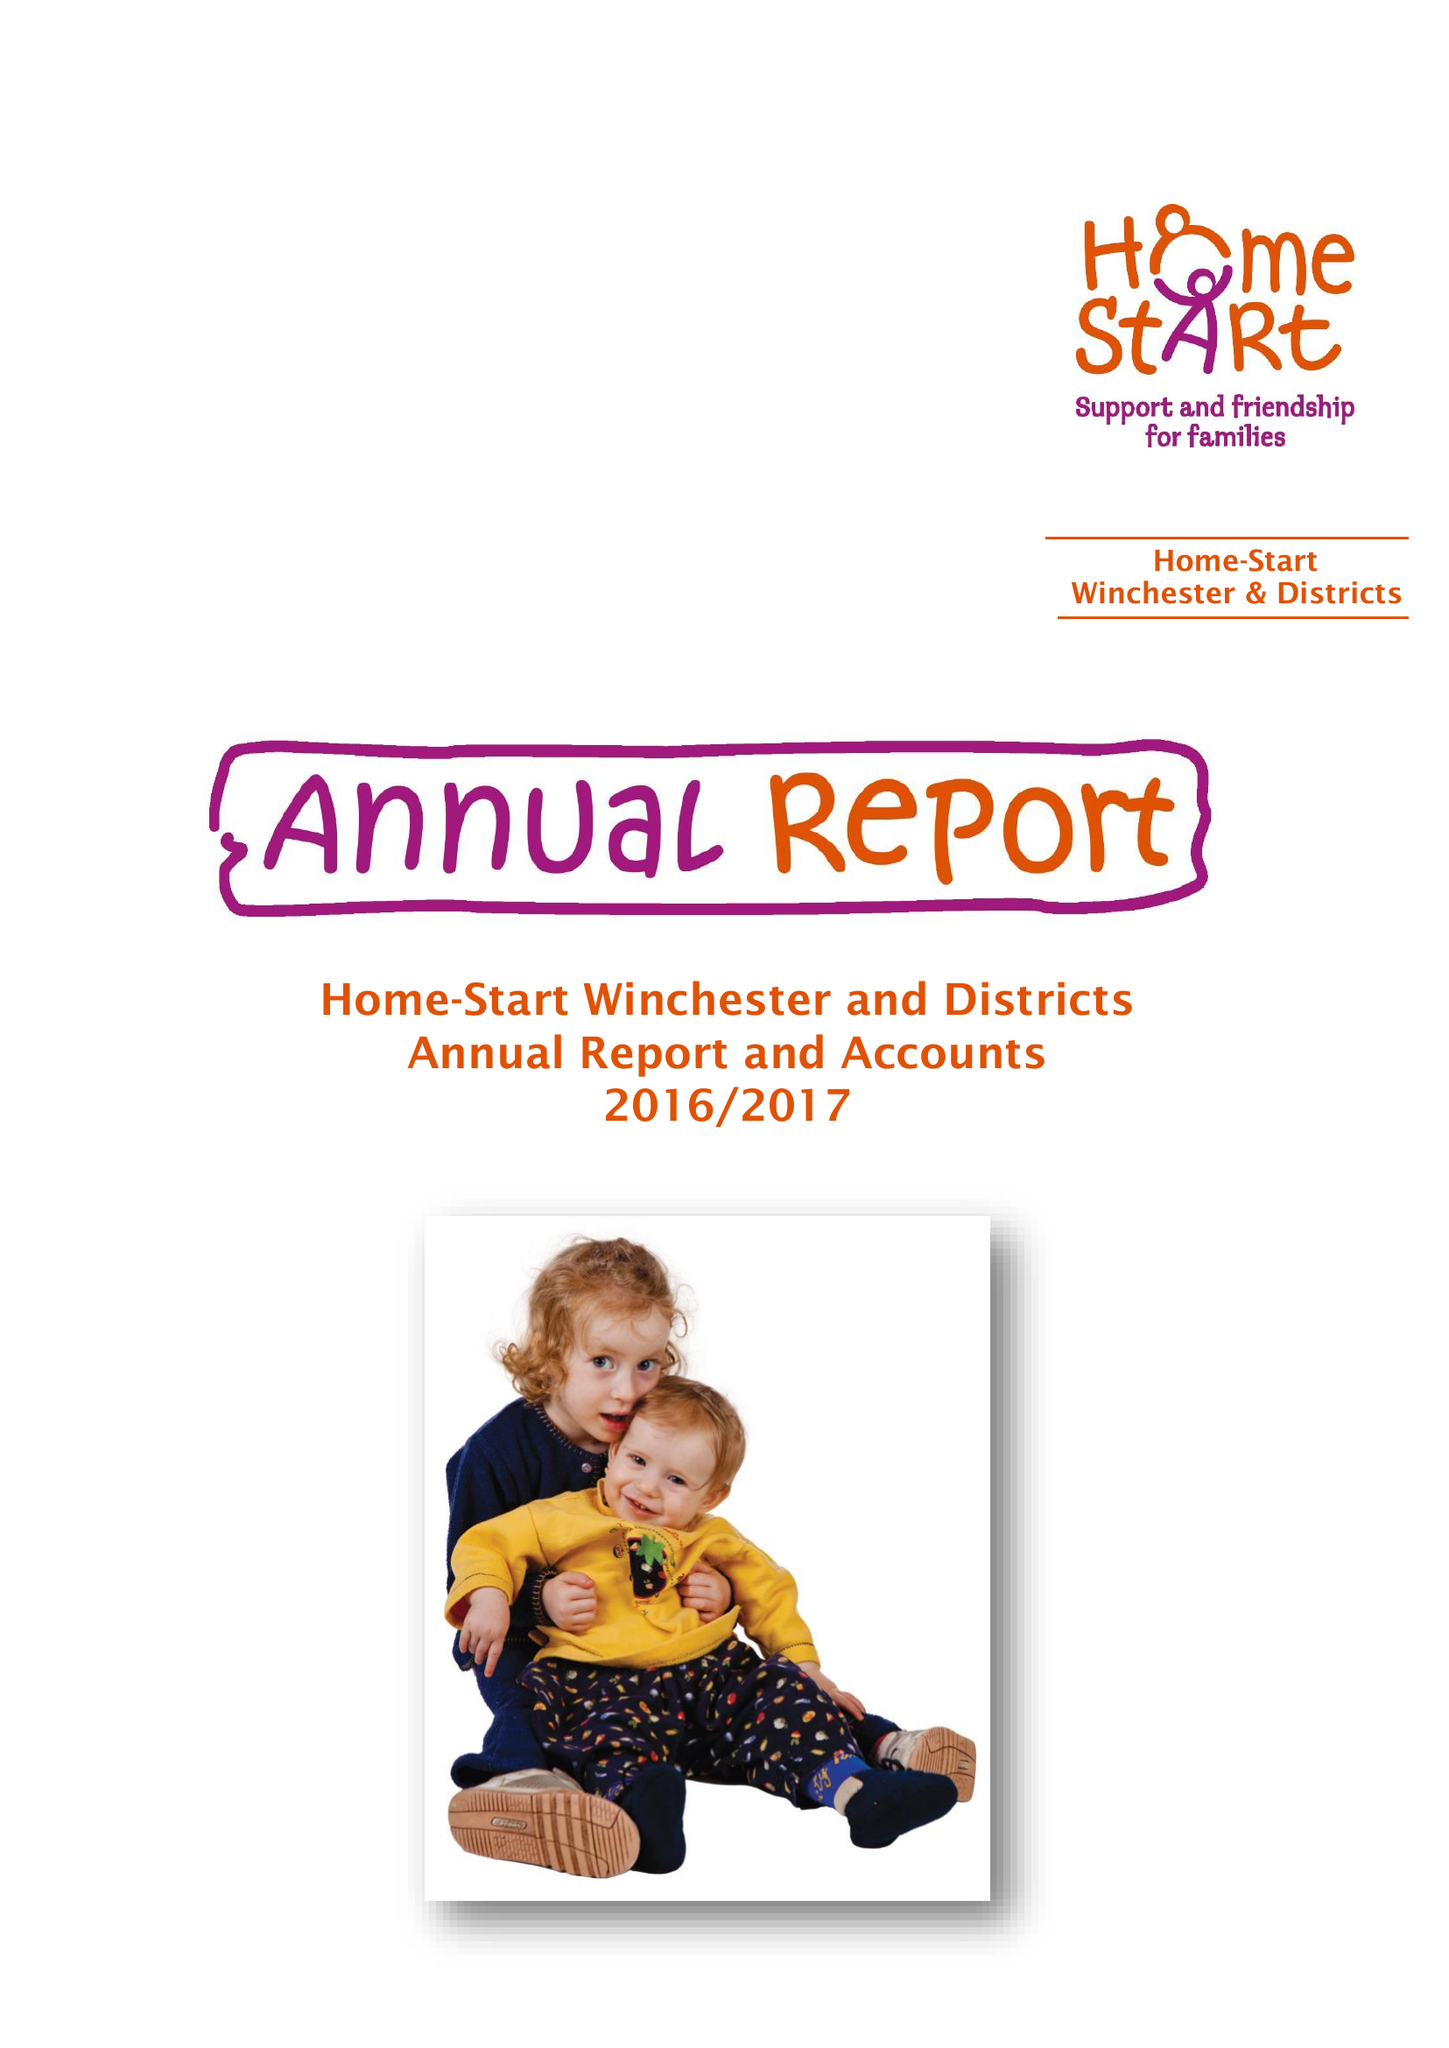What is the value for the income_annually_in_british_pounds?
Answer the question using a single word or phrase. 65862.00 